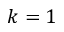<formula> <loc_0><loc_0><loc_500><loc_500>k = 1</formula> 